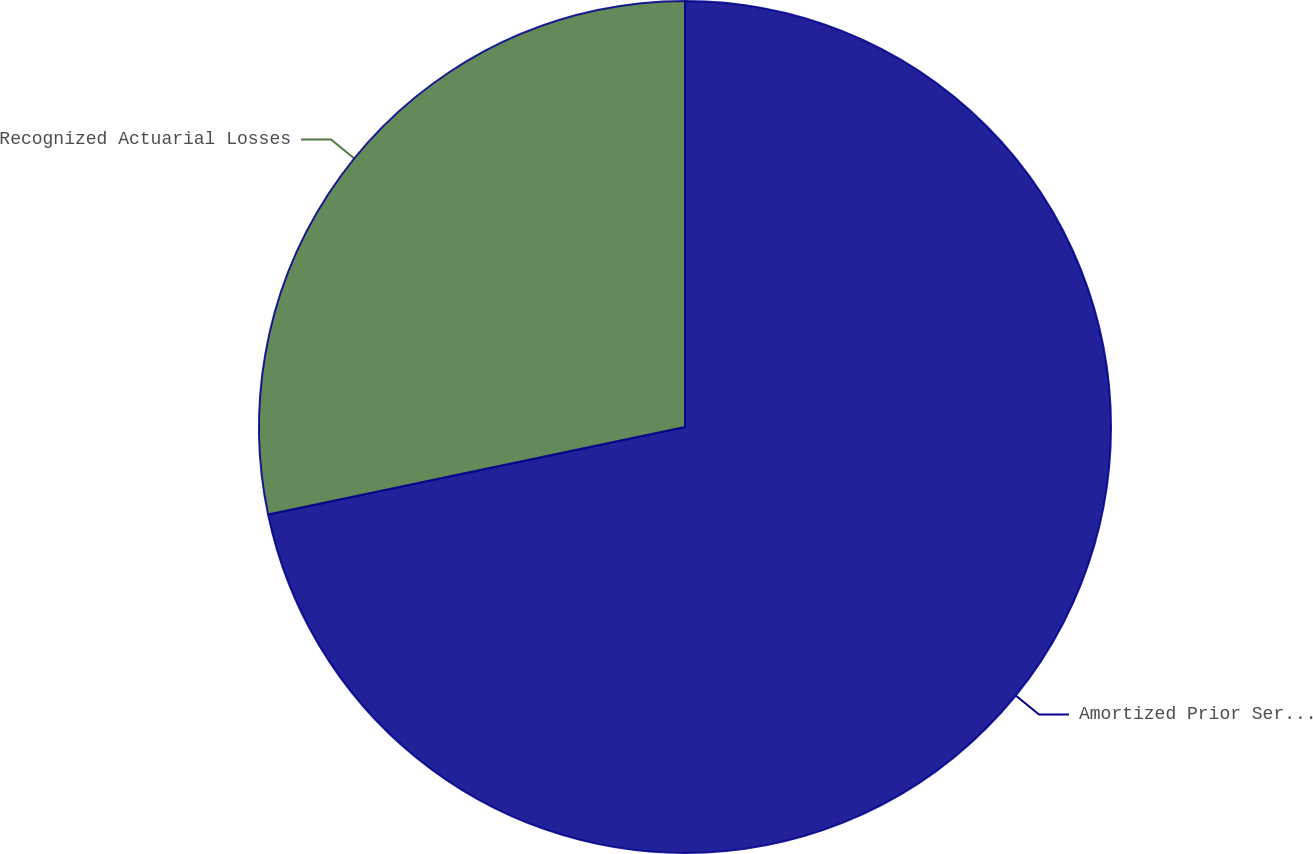<chart> <loc_0><loc_0><loc_500><loc_500><pie_chart><fcel>Amortized Prior Service Credit<fcel>Recognized Actuarial Losses<nl><fcel>71.71%<fcel>28.29%<nl></chart> 